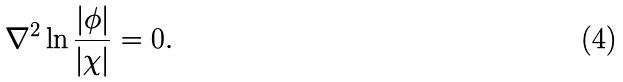Convert formula to latex. <formula><loc_0><loc_0><loc_500><loc_500>\nabla ^ { 2 } \ln \frac { | \phi | } { | \chi | } = 0 .</formula> 